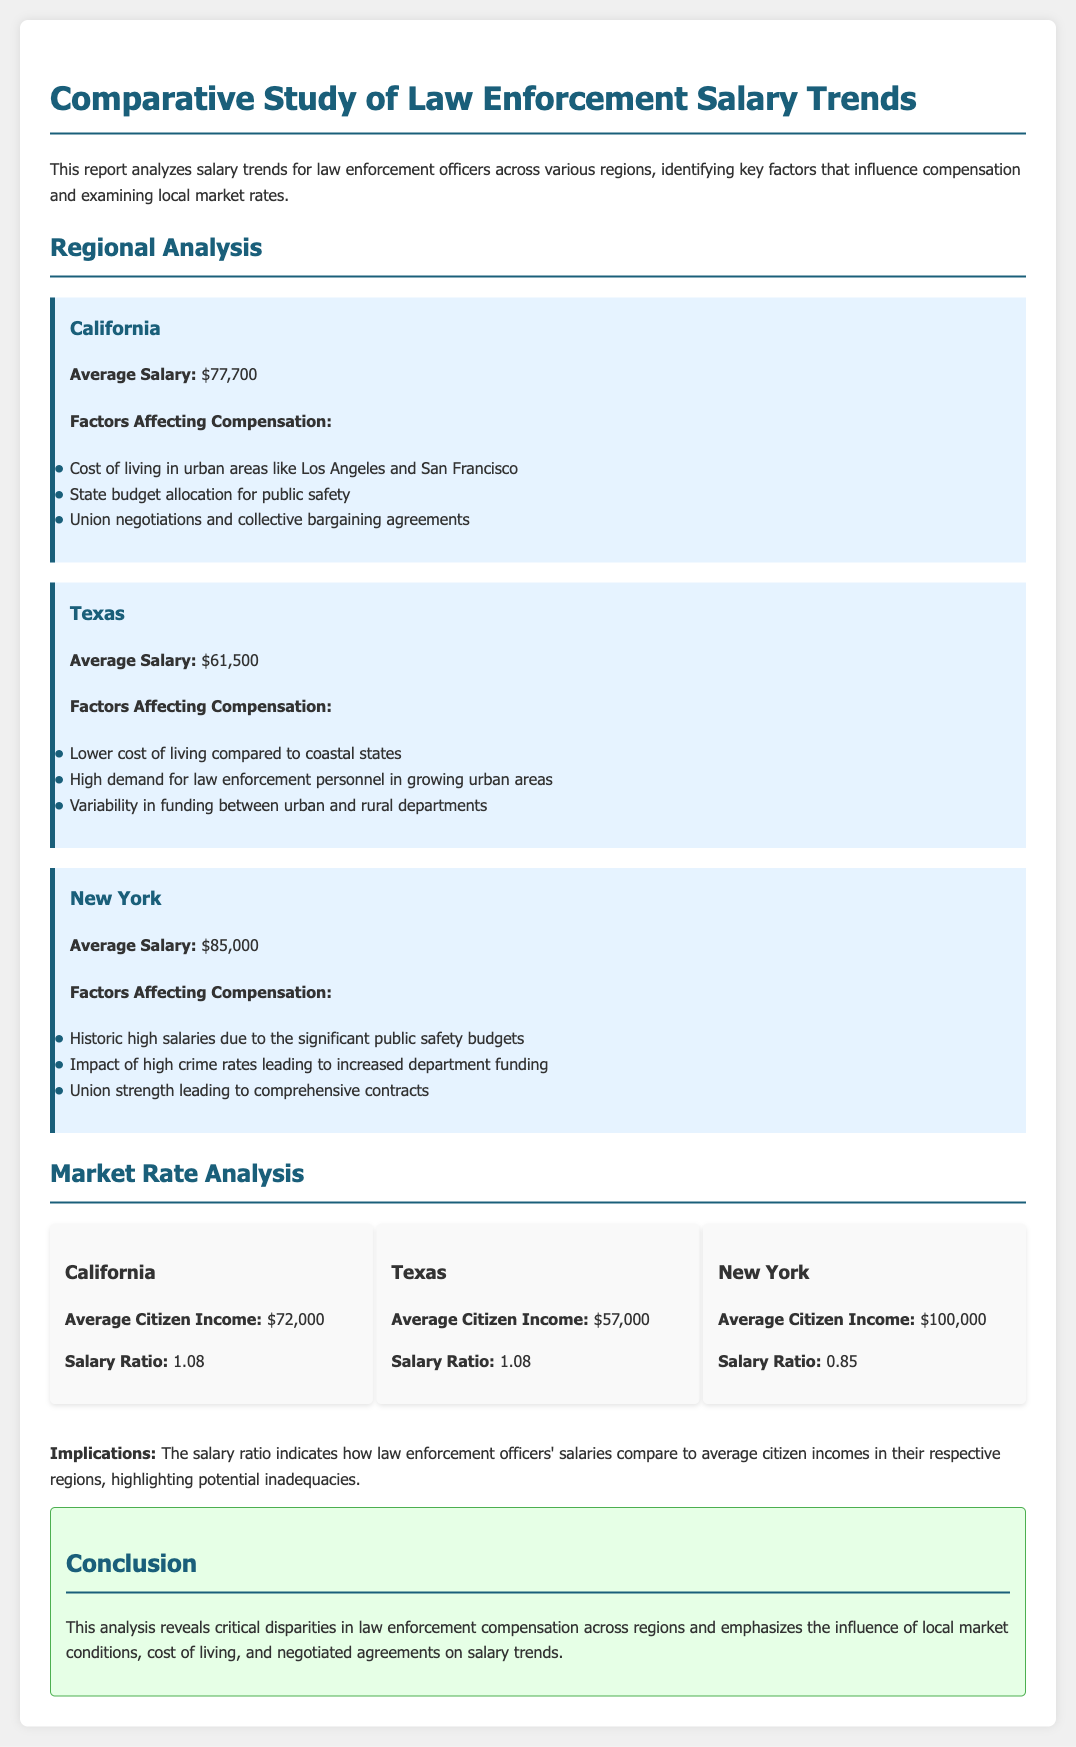What is the average salary in California? The average salary in California is stated in the report as $77,700.
Answer: $77,700 What factors affect compensation in New York? The document lists several factors impacting compensation in New York, which include historic high salaries, the impact of high crime rates, and union strength.
Answer: Historic high salaries, high crime rates, union strength What is the average citizen income in Texas? The report provides the average citizen income in Texas, which is explicitly mentioned.
Answer: $57,000 How does the salary ratio in New York compare to California? The salary ratios are provided for both regions, and comparison involves reasoning from the provided ratios: New York's ratio is 0.85 while California's ratio is 1.08, indicating lower relative compensation in New York.
Answer: Lower compensation in New York What are the implications mentioned in the report? The report discusses implications regarding the salary ratio and its reflection on law enforcement officers' compensation relative to average citizen incomes, symbolizing potential inadequacies.
Answer: Potential inadequacies What is the average salary for law enforcement officers in Texas? The document states the specific average salary for law enforcement officers in Texas clearly.
Answer: $61,500 Which region shows the highest average salary? By comparing the average salaries, identifying the region with the highest value can be determined easily.
Answer: New York What is the average salary ratio for Texas? The report includes the salary ratio for Texas, which allows for direct recovery of this piece of information.
Answer: 1.08 